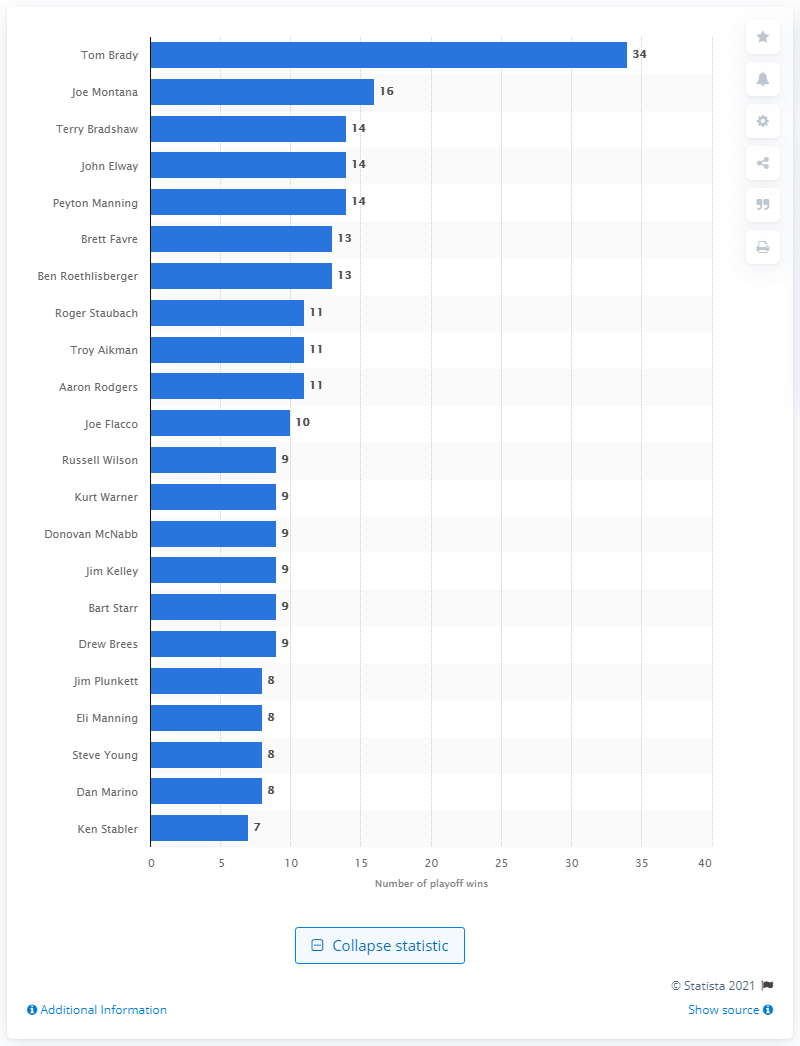Highlight a few significant elements in this photo. I, Tom Brady, have won a grand total of 34 playoff games, making me a true champion in the eyes of my peers and fans alike. Tom Brady has a close competitor named Joe Montana, who is his rival in the world of football. Tom Brady is widely acclaimed as one of the most outstanding American football players of all time. 